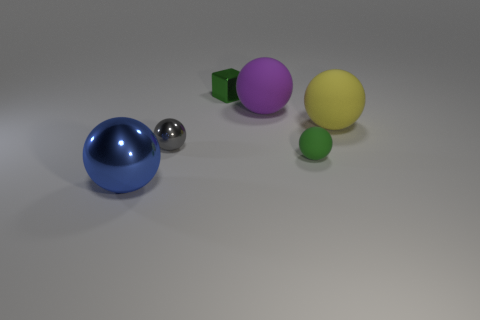Add 2 brown metallic spheres. How many objects exist? 8 Add 5 yellow balls. How many yellow balls exist? 6 Subtract all green spheres. How many spheres are left? 4 Subtract all yellow balls. How many balls are left? 4 Subtract 0 cyan cylinders. How many objects are left? 6 Subtract all spheres. How many objects are left? 1 Subtract 2 balls. How many balls are left? 3 Subtract all red cubes. Subtract all cyan spheres. How many cubes are left? 1 Subtract all red balls. How many purple cubes are left? 0 Subtract all purple shiny objects. Subtract all green rubber spheres. How many objects are left? 5 